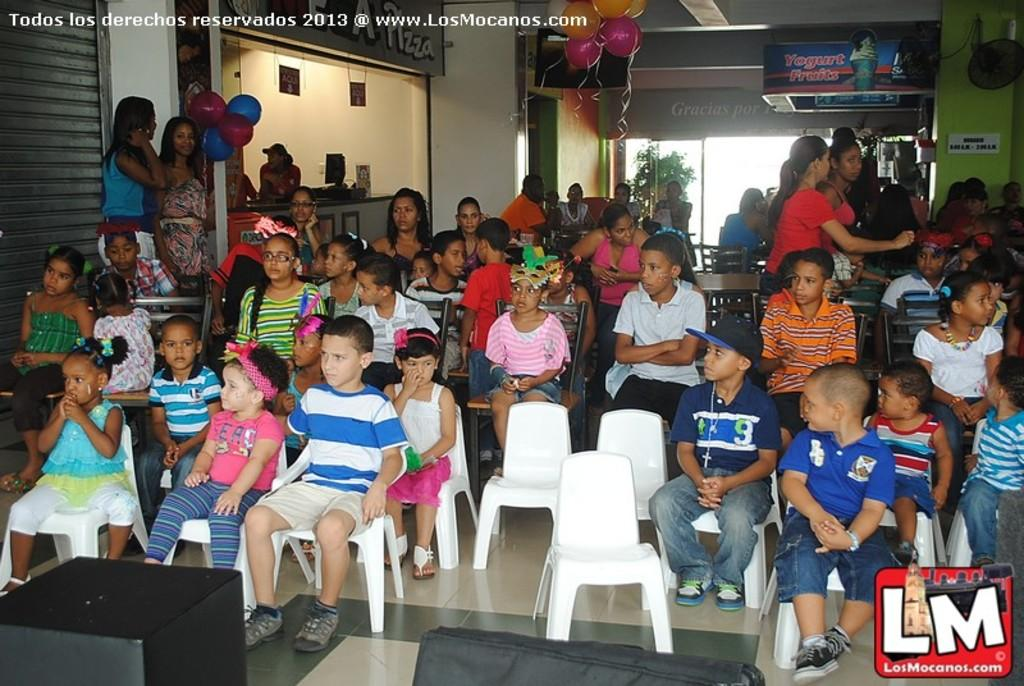What types of people are in the image? There are boys and girls in the image. How are the children positioned in the image? Some of the children are seated on chairs, while others are standing. What decorative items can be seen in the image? There are balloons in the image. What type of signage is present in the image? There is a hoarding in the image. What type of vegetation is in the image? There is a plant in the image. How many goldfish are swimming in the plant in the image? There are no goldfish present in the image; it features a plant without any aquatic creatures. What type of train can be seen passing by in the image? There is no train visible in the image. 